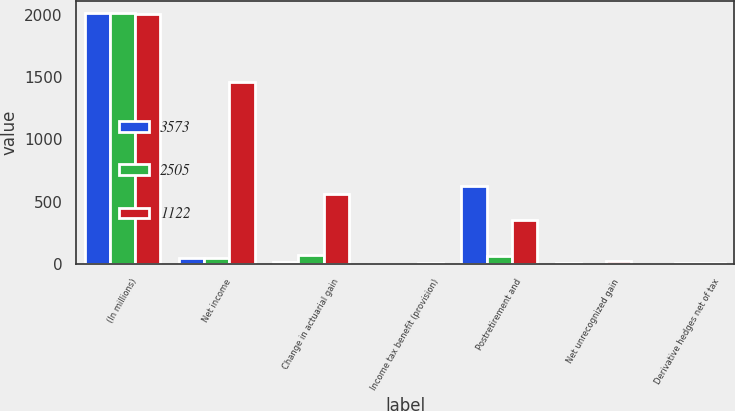<chart> <loc_0><loc_0><loc_500><loc_500><stacked_bar_chart><ecel><fcel>(In millions)<fcel>Net income<fcel>Change in actuarial gain<fcel>Income tax benefit (provision)<fcel>Postretirement and<fcel>Net unrecognized gain<fcel>Derivative hedges net of tax<nl><fcel>3573<fcel>2011<fcel>46.5<fcel>16<fcel>1<fcel>627<fcel>9<fcel>1<nl><fcel>2505<fcel>2010<fcel>46.5<fcel>76<fcel>1<fcel>69<fcel>5<fcel>6<nl><fcel>1122<fcel>2009<fcel>1463<fcel>564<fcel>12<fcel>356<fcel>24<fcel>12<nl></chart> 